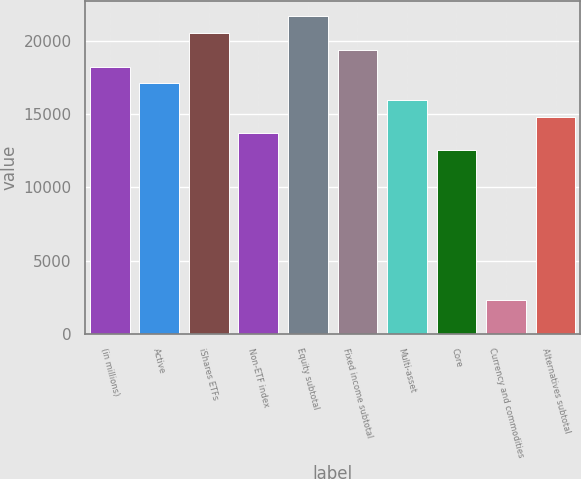<chart> <loc_0><loc_0><loc_500><loc_500><bar_chart><fcel>(in millions)<fcel>Active<fcel>iShares ETFs<fcel>Non-ETF index<fcel>Equity subtotal<fcel>Fixed income subtotal<fcel>Multi-asset<fcel>Core<fcel>Currency and commodities<fcel>Alternatives subtotal<nl><fcel>18226<fcel>17088.5<fcel>20501<fcel>13676<fcel>21638.5<fcel>19363.5<fcel>15951<fcel>12538.5<fcel>2301<fcel>14813.5<nl></chart> 